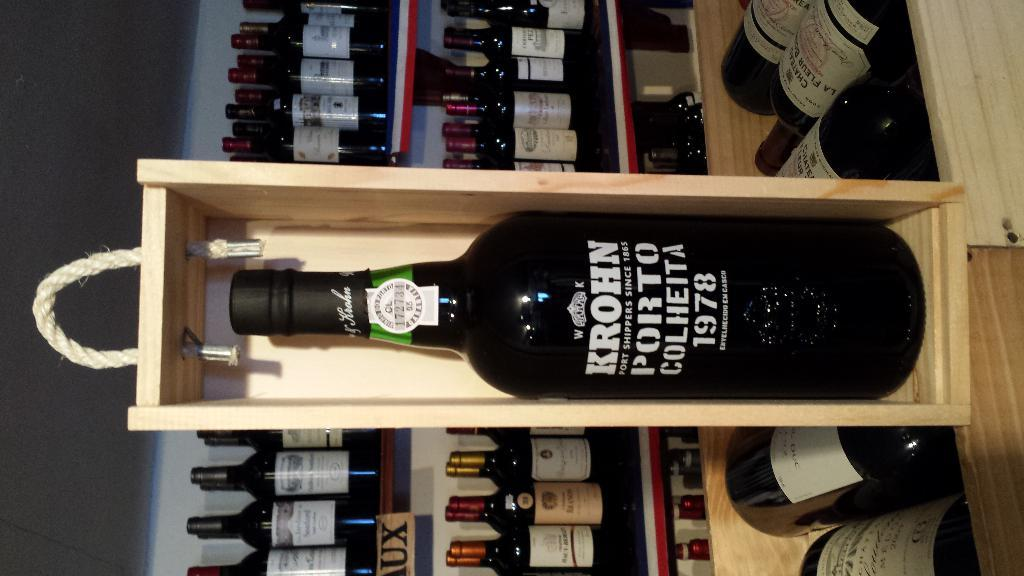What type of containers are present in the image? There are wooden boxes in the image. What are the wooden boxes used for? The wooden boxes contain bottles. What can be seen in the background of the image? There is a rack in the background of the image. What is stored on the rack? The rack contains bottles. Can you hear the zebra whistling in the image? There is no zebra or whistling present in the image. 